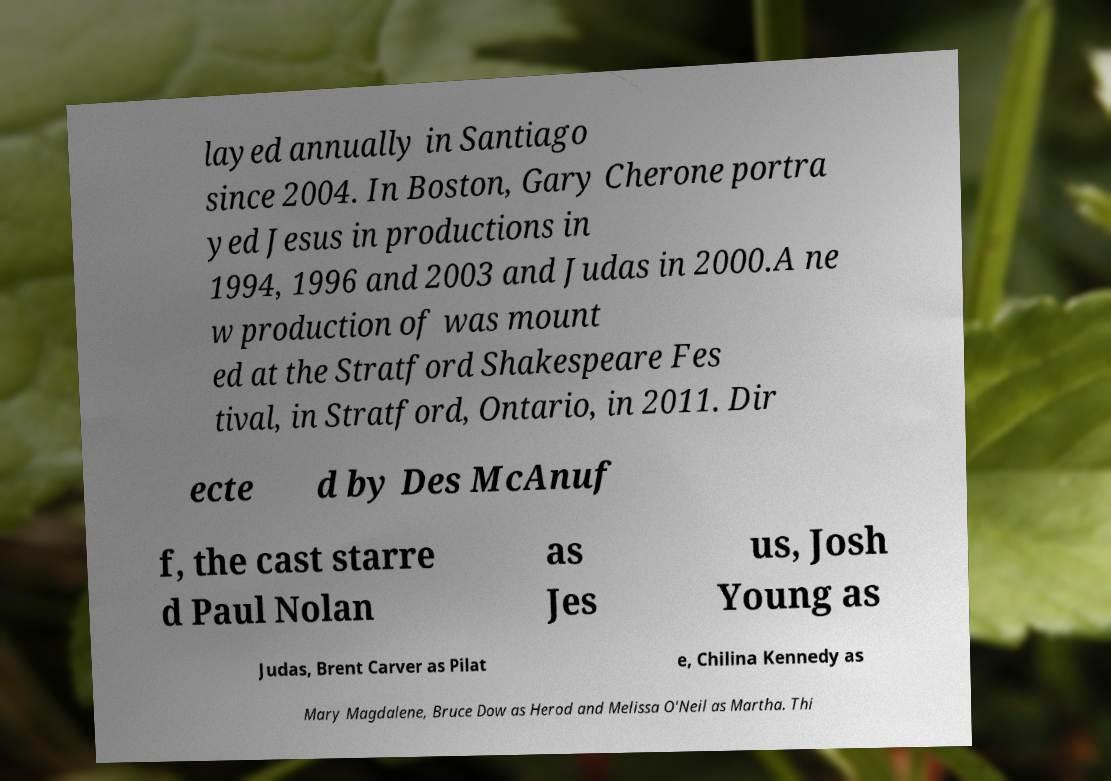Please read and relay the text visible in this image. What does it say? layed annually in Santiago since 2004. In Boston, Gary Cherone portra yed Jesus in productions in 1994, 1996 and 2003 and Judas in 2000.A ne w production of was mount ed at the Stratford Shakespeare Fes tival, in Stratford, Ontario, in 2011. Dir ecte d by Des McAnuf f, the cast starre d Paul Nolan as Jes us, Josh Young as Judas, Brent Carver as Pilat e, Chilina Kennedy as Mary Magdalene, Bruce Dow as Herod and Melissa O'Neil as Martha. Thi 